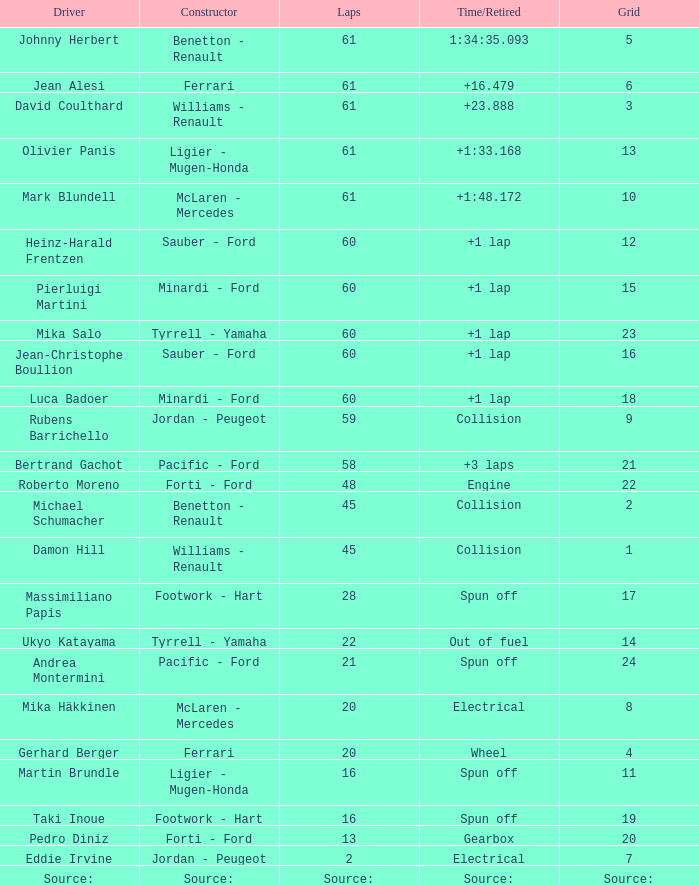How many rounds does luca badoer have? 60.0. 